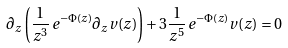Convert formula to latex. <formula><loc_0><loc_0><loc_500><loc_500>\partial _ { z } \left ( \frac { 1 } { z ^ { 3 } } \, e ^ { - \Phi ( z ) } \partial _ { z } v ( z ) \right ) + 3 \frac { 1 } { z ^ { 5 } } \, e ^ { - \Phi ( z ) } v ( z ) = 0</formula> 